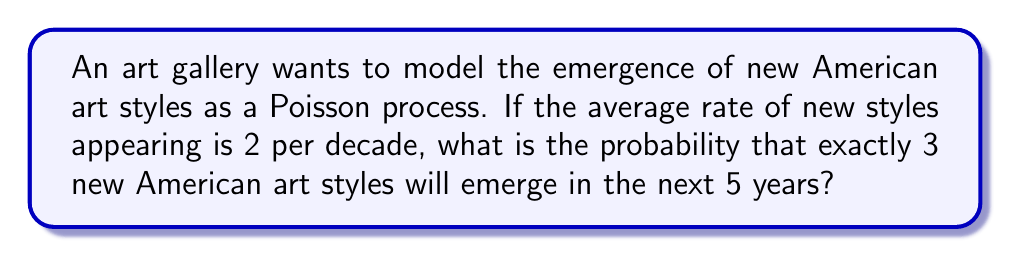What is the answer to this math problem? Let's approach this step-by-step:

1) First, we need to identify the parameters of our Poisson process:
   - The rate (λ) is 2 new styles per decade
   - We're interested in a 5-year period

2) We need to adjust the rate for a 5-year period:
   $\lambda_{5 years} = 2 \times \frac{5}{10} = 1$ new style per 5 years

3) The probability of exactly k events occurring in a Poisson process is given by the formula:

   $P(X = k) = \frac{e^{-\lambda}\lambda^k}{k!}$

   Where:
   - e is Euler's number (approximately 2.71828)
   - λ is the average rate of events
   - k is the number of events we're interested in

4) In this case:
   - λ = 1
   - k = 3

5) Let's substitute these values into the formula:

   $P(X = 3) = \frac{e^{-1}1^3}{3!}$

6) Simplify:
   $P(X = 3) = \frac{e^{-1}}{6}$

7) Calculate the value (you can use a calculator for this):
   $P(X = 3) \approx 0.0613$

Thus, the probability of exactly 3 new American art styles emerging in the next 5 years is approximately 0.0613 or 6.13%.
Answer: $\frac{e^{-1}}{6} \approx 0.0613$ 